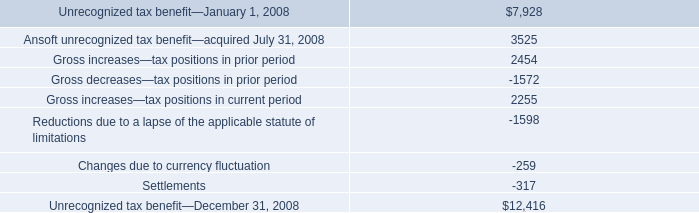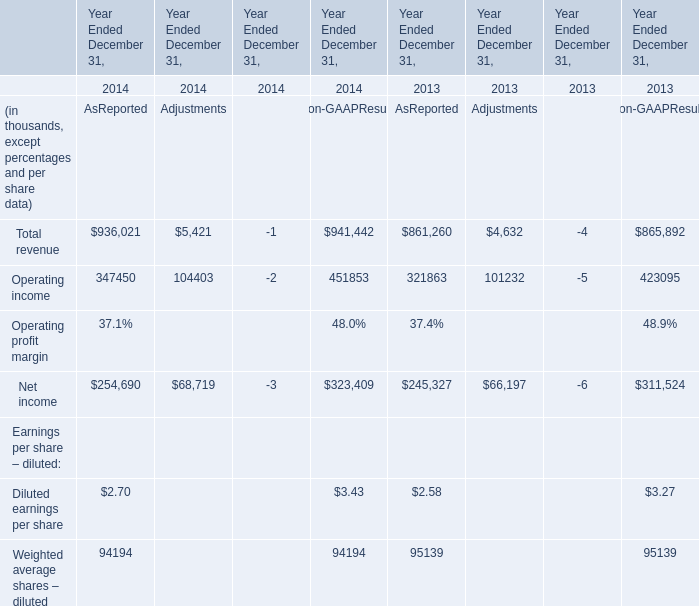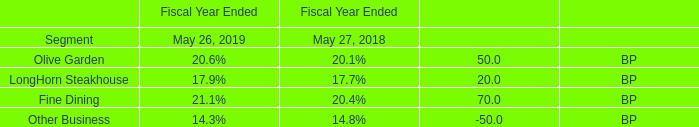If Total revenue As Reported develops with the same growth rate in 2014, what will it reach in 2015? (in dollars in thousands) 
Computations: (936021 * (1 + ((936021 - 861260) / 861260)))
Answer: 1017271.57007. 